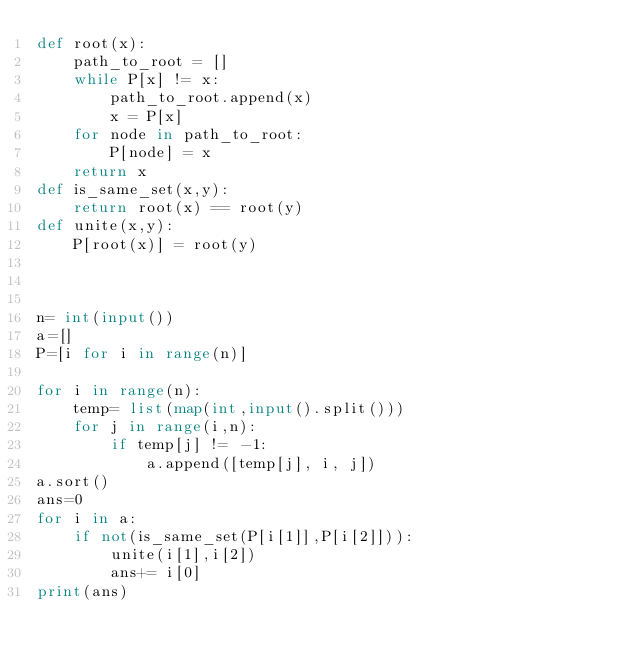Convert code to text. <code><loc_0><loc_0><loc_500><loc_500><_Python_>def root(x):
    path_to_root = []
    while P[x] != x:
        path_to_root.append(x)
        x = P[x]
    for node in path_to_root:
        P[node] = x
    return x
def is_same_set(x,y):
    return root(x) == root(y)
def unite(x,y):
    P[root(x)] = root(y)
    
    

n= int(input())
a=[]
P=[i for i in range(n)]

for i in range(n):
    temp= list(map(int,input().split()))
    for j in range(i,n):
        if temp[j] != -1:
            a.append([temp[j], i, j])
a.sort()
ans=0
for i in a:
    if not(is_same_set(P[i[1]],P[i[2]])):
        unite(i[1],i[2])
        ans+= i[0]
print(ans)
</code> 